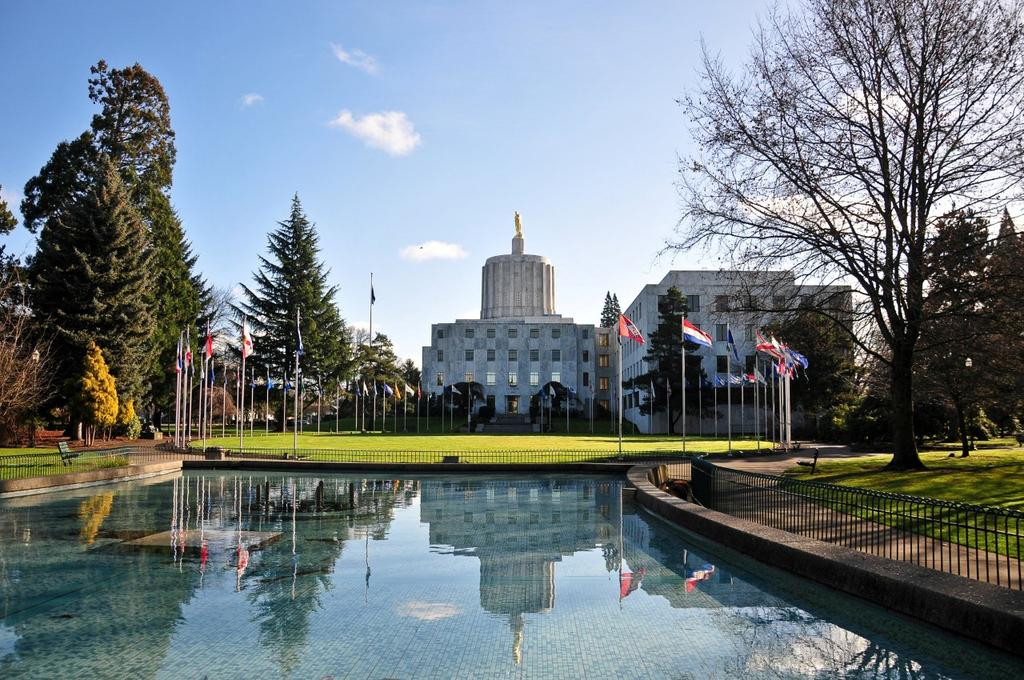What is one of the natural elements present in the image? There is water in the image. What type of structures can be seen in the image? There is a building in the image. What type of vegetation is present in the image? There are trees and grass in the image. What type of seating is available in the image? There are benches in the image. What is visible in the sky in the image? There are clouds in the image, and the sky is visible. What type of idea is being discussed by the father in the image? There is no father or discussion present in the image. What type of scissors are being used to cut the grass in the image? There are no scissors or grass-cutting activity in the image. 